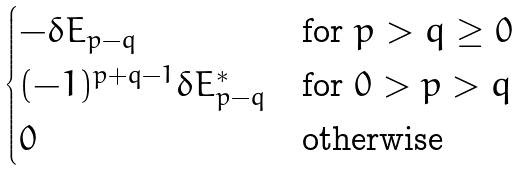<formula> <loc_0><loc_0><loc_500><loc_500>\begin{cases} - \delta { E } _ { p - q } & \text {for $p>q\geq 0$} \\ ( - 1 ) ^ { p + q - 1 } \delta { E } _ { p - q } ^ { * } & \text {for $0>p >q$} \\ 0 & \text {otherwise} \end{cases}</formula> 